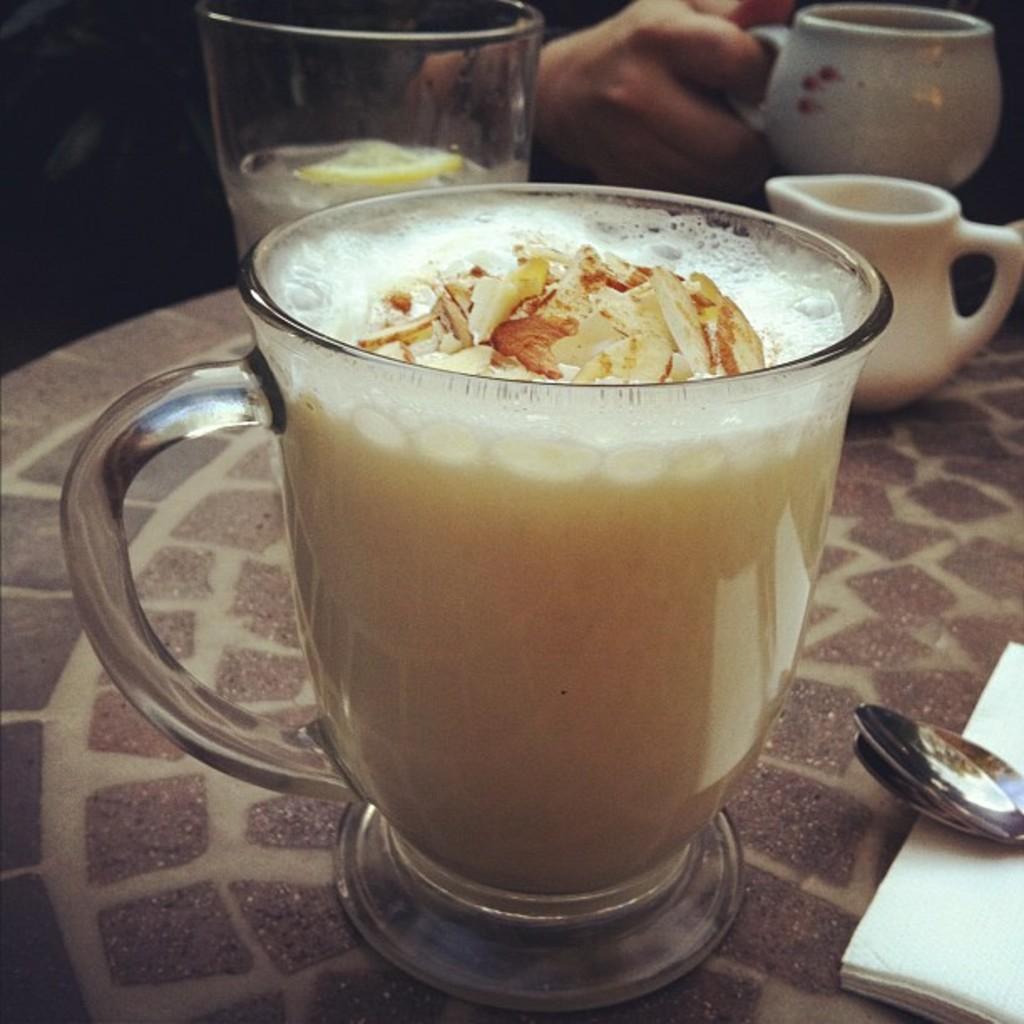In one or two sentences, can you explain what this image depicts? In this picture we can see a cup with full of drink in it and a spoon on the table, in the background a person is holding a cup. 